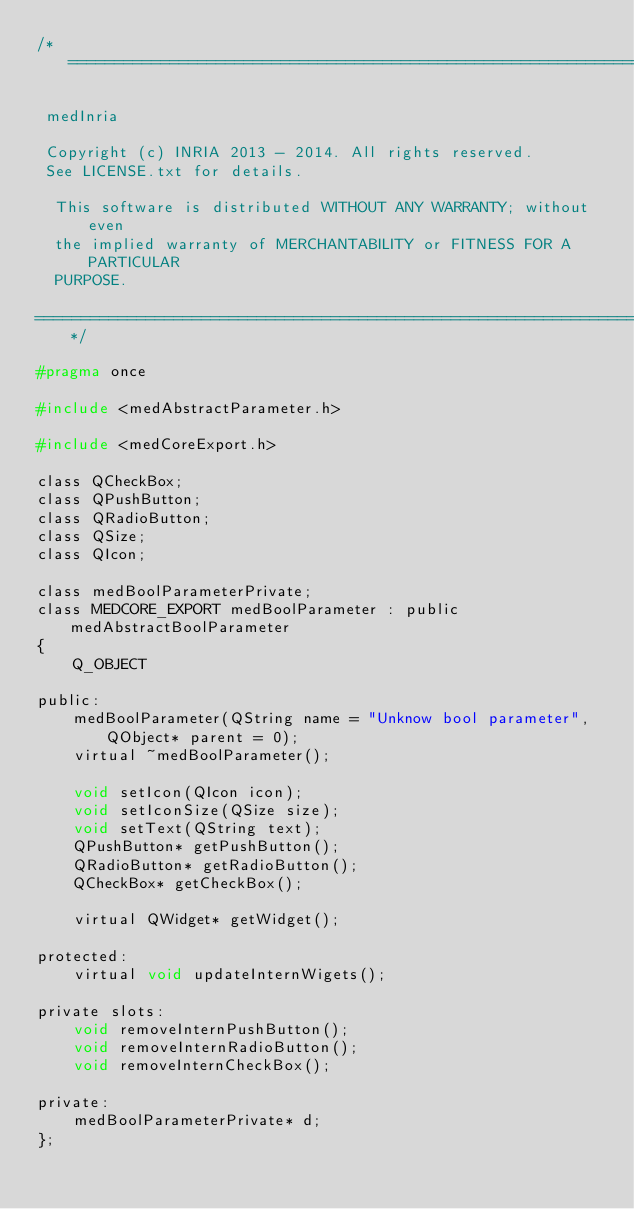<code> <loc_0><loc_0><loc_500><loc_500><_C_>/*=========================================================================

 medInria

 Copyright (c) INRIA 2013 - 2014. All rights reserved.
 See LICENSE.txt for details.
 
  This software is distributed WITHOUT ANY WARRANTY; without even
  the implied warranty of MERCHANTABILITY or FITNESS FOR A PARTICULAR
  PURPOSE.

=========================================================================*/

#pragma once

#include <medAbstractParameter.h>

#include <medCoreExport.h>

class QCheckBox;
class QPushButton;
class QRadioButton;
class QSize;
class QIcon;

class medBoolParameterPrivate;
class MEDCORE_EXPORT medBoolParameter : public medAbstractBoolParameter
{
    Q_OBJECT

public:
    medBoolParameter(QString name = "Unknow bool parameter", QObject* parent = 0);
    virtual ~medBoolParameter();

    void setIcon(QIcon icon);
    void setIconSize(QSize size);
    void setText(QString text);
    QPushButton* getPushButton();
    QRadioButton* getRadioButton();
    QCheckBox* getCheckBox();

    virtual QWidget* getWidget();

protected:
    virtual void updateInternWigets();

private slots:
    void removeInternPushButton();
    void removeInternRadioButton();
    void removeInternCheckBox();

private:
    medBoolParameterPrivate* d;
};
</code> 